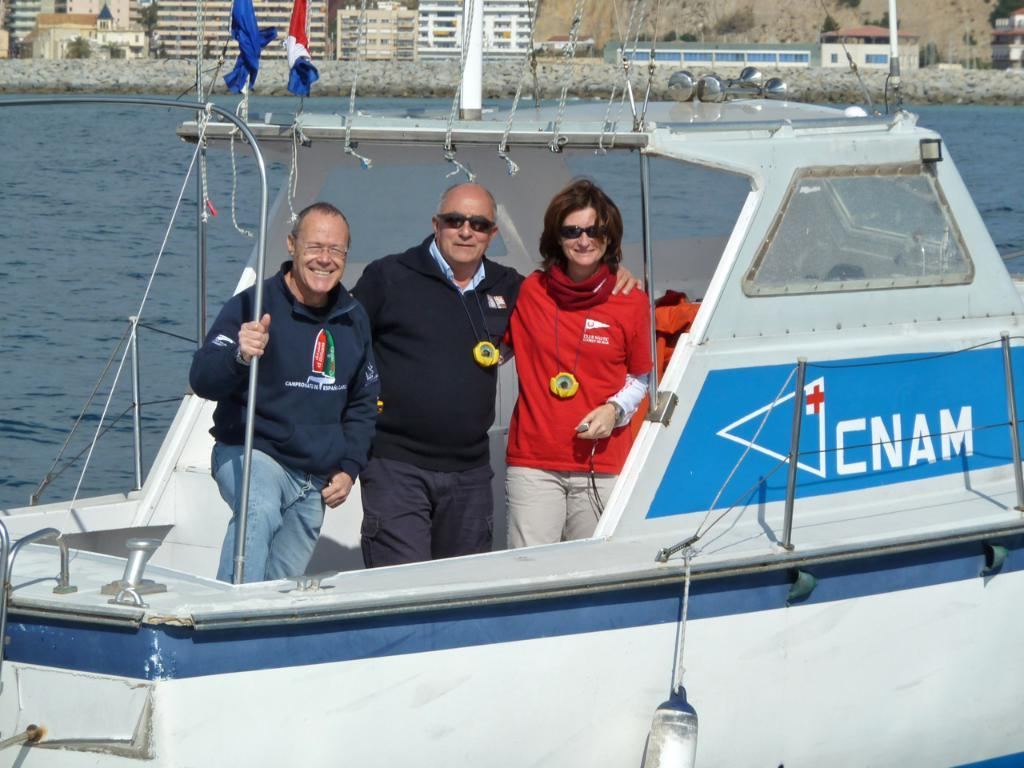<image>
Give a short and clear explanation of the subsequent image. Three people are riding in a boat with CNAM on the side in white lettering. 